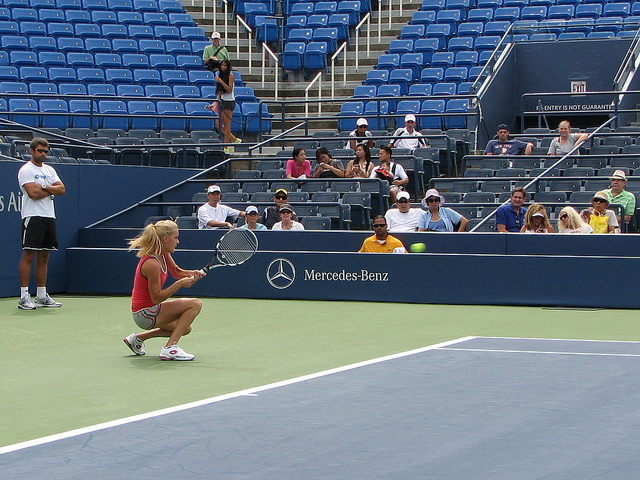Please identify all text content in this image. Mercedes Benz NOT S 